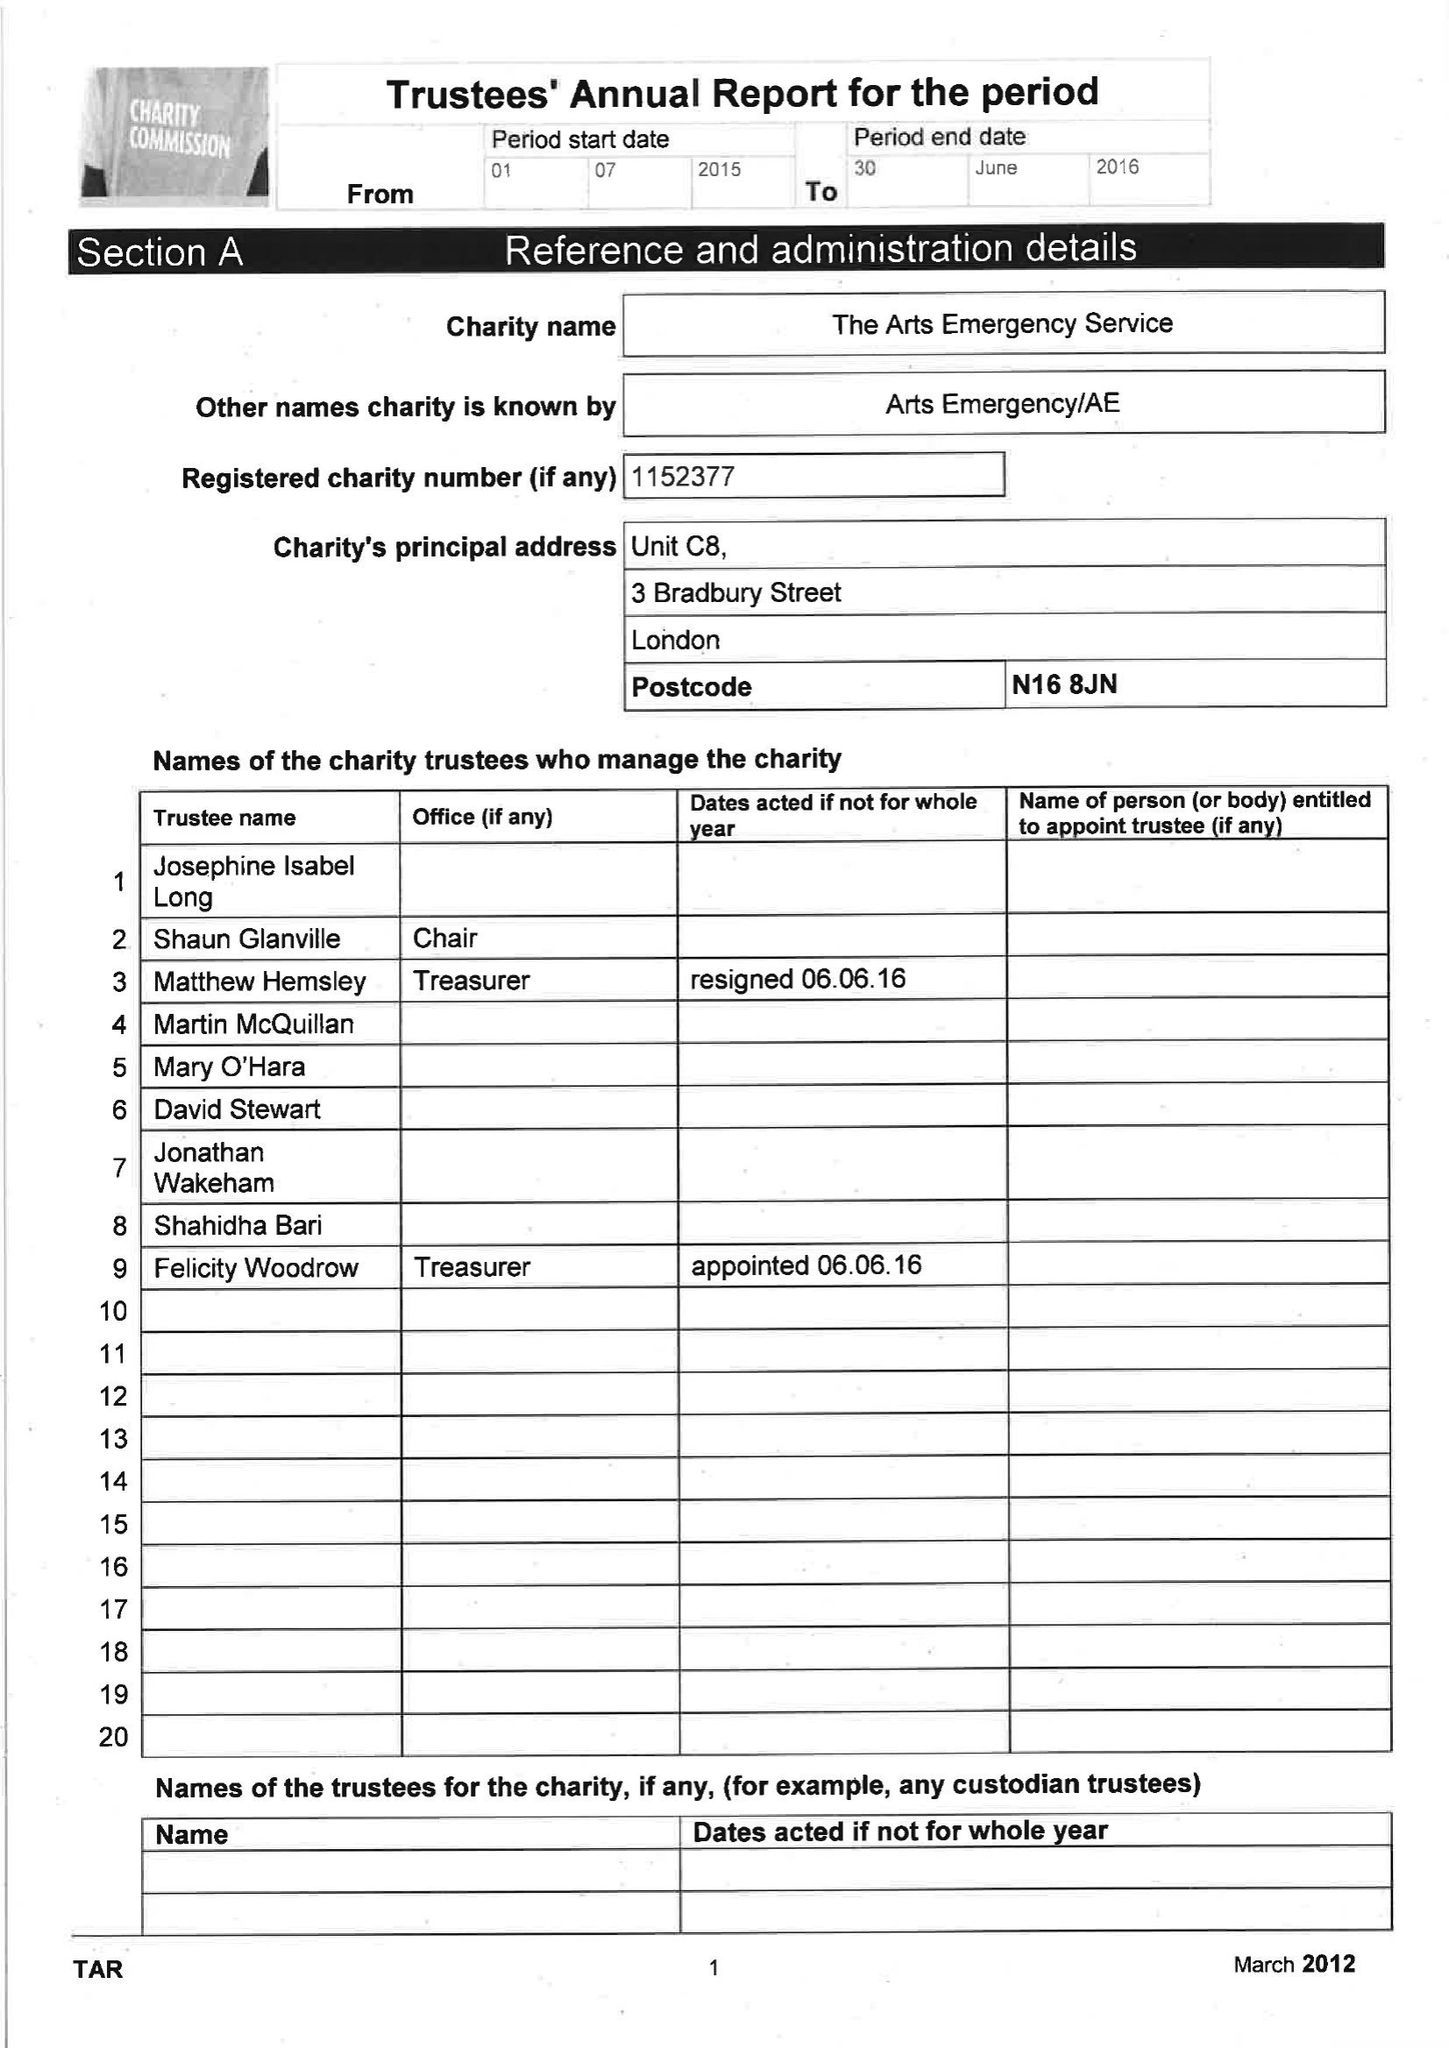What is the value for the charity_number?
Answer the question using a single word or phrase. 1152377 